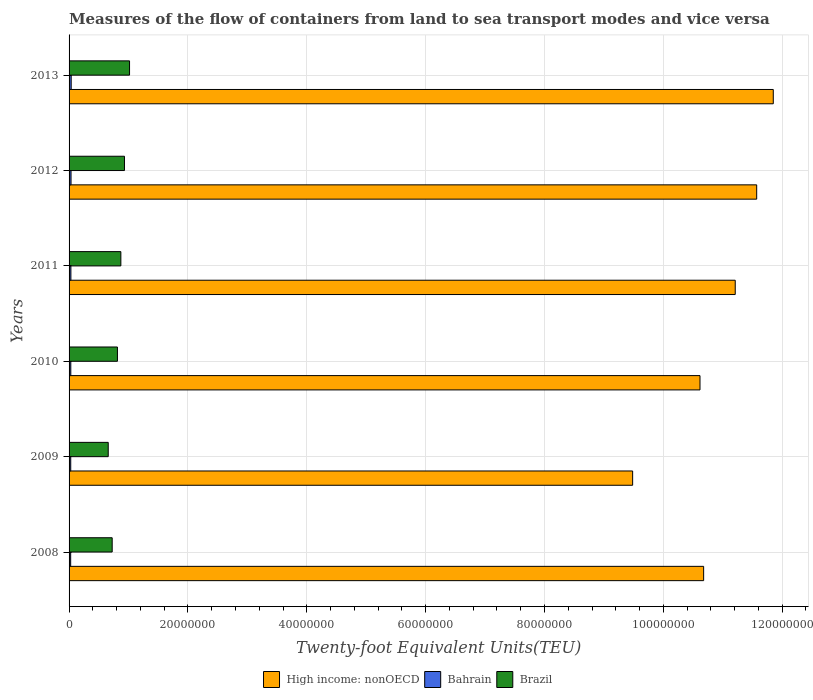How many different coloured bars are there?
Provide a short and direct response. 3. How many groups of bars are there?
Offer a very short reply. 6. How many bars are there on the 1st tick from the top?
Ensure brevity in your answer.  3. What is the label of the 5th group of bars from the top?
Offer a very short reply. 2009. In how many cases, is the number of bars for a given year not equal to the number of legend labels?
Your response must be concise. 0. What is the container port traffic in High income: nonOECD in 2011?
Offer a terse response. 1.12e+08. Across all years, what is the maximum container port traffic in High income: nonOECD?
Keep it short and to the point. 1.19e+08. Across all years, what is the minimum container port traffic in Brazil?
Give a very brief answer. 6.59e+06. In which year was the container port traffic in High income: nonOECD minimum?
Keep it short and to the point. 2009. What is the total container port traffic in Bahrain in the graph?
Give a very brief answer. 1.83e+06. What is the difference between the container port traffic in Bahrain in 2011 and that in 2012?
Provide a succinct answer. -2.30e+04. What is the difference between the container port traffic in Brazil in 2010 and the container port traffic in High income: nonOECD in 2012?
Provide a succinct answer. -1.08e+08. What is the average container port traffic in Bahrain per year?
Your answer should be very brief. 3.05e+05. In the year 2008, what is the difference between the container port traffic in Bahrain and container port traffic in Brazil?
Offer a very short reply. -6.99e+06. What is the ratio of the container port traffic in Brazil in 2010 to that in 2011?
Provide a succinct answer. 0.93. Is the container port traffic in Bahrain in 2010 less than that in 2012?
Offer a very short reply. Yes. What is the difference between the highest and the second highest container port traffic in Brazil?
Your response must be concise. 8.54e+05. What is the difference between the highest and the lowest container port traffic in Brazil?
Provide a short and direct response. 3.59e+06. Is the sum of the container port traffic in Brazil in 2008 and 2010 greater than the maximum container port traffic in Bahrain across all years?
Offer a terse response. Yes. What does the 3rd bar from the top in 2013 represents?
Provide a short and direct response. High income: nonOECD. What does the 3rd bar from the bottom in 2008 represents?
Provide a succinct answer. Brazil. Are all the bars in the graph horizontal?
Offer a very short reply. Yes. How many years are there in the graph?
Give a very brief answer. 6. What is the difference between two consecutive major ticks on the X-axis?
Give a very brief answer. 2.00e+07. Does the graph contain any zero values?
Make the answer very short. No. What is the title of the graph?
Offer a terse response. Measures of the flow of containers from land to sea transport modes and vice versa. Does "Small states" appear as one of the legend labels in the graph?
Keep it short and to the point. No. What is the label or title of the X-axis?
Keep it short and to the point. Twenty-foot Equivalent Units(TEU). What is the label or title of the Y-axis?
Offer a terse response. Years. What is the Twenty-foot Equivalent Units(TEU) in High income: nonOECD in 2008?
Make the answer very short. 1.07e+08. What is the Twenty-foot Equivalent Units(TEU) of Bahrain in 2008?
Offer a very short reply. 2.69e+05. What is the Twenty-foot Equivalent Units(TEU) of Brazil in 2008?
Ensure brevity in your answer.  7.26e+06. What is the Twenty-foot Equivalent Units(TEU) in High income: nonOECD in 2009?
Provide a succinct answer. 9.48e+07. What is the Twenty-foot Equivalent Units(TEU) in Bahrain in 2009?
Ensure brevity in your answer.  2.80e+05. What is the Twenty-foot Equivalent Units(TEU) in Brazil in 2009?
Offer a very short reply. 6.59e+06. What is the Twenty-foot Equivalent Units(TEU) in High income: nonOECD in 2010?
Your response must be concise. 1.06e+08. What is the Twenty-foot Equivalent Units(TEU) in Bahrain in 2010?
Your response must be concise. 2.90e+05. What is the Twenty-foot Equivalent Units(TEU) of Brazil in 2010?
Your answer should be compact. 8.14e+06. What is the Twenty-foot Equivalent Units(TEU) of High income: nonOECD in 2011?
Provide a short and direct response. 1.12e+08. What is the Twenty-foot Equivalent Units(TEU) of Bahrain in 2011?
Your response must be concise. 3.06e+05. What is the Twenty-foot Equivalent Units(TEU) of Brazil in 2011?
Your answer should be very brief. 8.71e+06. What is the Twenty-foot Equivalent Units(TEU) in High income: nonOECD in 2012?
Ensure brevity in your answer.  1.16e+08. What is the Twenty-foot Equivalent Units(TEU) of Bahrain in 2012?
Your response must be concise. 3.29e+05. What is the Twenty-foot Equivalent Units(TEU) of Brazil in 2012?
Your answer should be compact. 9.32e+06. What is the Twenty-foot Equivalent Units(TEU) of High income: nonOECD in 2013?
Provide a succinct answer. 1.19e+08. What is the Twenty-foot Equivalent Units(TEU) of Bahrain in 2013?
Give a very brief answer. 3.55e+05. What is the Twenty-foot Equivalent Units(TEU) in Brazil in 2013?
Make the answer very short. 1.02e+07. Across all years, what is the maximum Twenty-foot Equivalent Units(TEU) in High income: nonOECD?
Give a very brief answer. 1.19e+08. Across all years, what is the maximum Twenty-foot Equivalent Units(TEU) of Bahrain?
Make the answer very short. 3.55e+05. Across all years, what is the maximum Twenty-foot Equivalent Units(TEU) of Brazil?
Your answer should be very brief. 1.02e+07. Across all years, what is the minimum Twenty-foot Equivalent Units(TEU) of High income: nonOECD?
Give a very brief answer. 9.48e+07. Across all years, what is the minimum Twenty-foot Equivalent Units(TEU) in Bahrain?
Provide a short and direct response. 2.69e+05. Across all years, what is the minimum Twenty-foot Equivalent Units(TEU) of Brazil?
Offer a very short reply. 6.59e+06. What is the total Twenty-foot Equivalent Units(TEU) in High income: nonOECD in the graph?
Offer a very short reply. 6.54e+08. What is the total Twenty-foot Equivalent Units(TEU) in Bahrain in the graph?
Make the answer very short. 1.83e+06. What is the total Twenty-foot Equivalent Units(TEU) in Brazil in the graph?
Keep it short and to the point. 5.02e+07. What is the difference between the Twenty-foot Equivalent Units(TEU) in High income: nonOECD in 2008 and that in 2009?
Ensure brevity in your answer.  1.19e+07. What is the difference between the Twenty-foot Equivalent Units(TEU) in Bahrain in 2008 and that in 2009?
Offer a terse response. -1.05e+04. What is the difference between the Twenty-foot Equivalent Units(TEU) in Brazil in 2008 and that in 2009?
Your answer should be compact. 6.66e+05. What is the difference between the Twenty-foot Equivalent Units(TEU) of High income: nonOECD in 2008 and that in 2010?
Your answer should be compact. 6.11e+05. What is the difference between the Twenty-foot Equivalent Units(TEU) in Bahrain in 2008 and that in 2010?
Offer a very short reply. -2.06e+04. What is the difference between the Twenty-foot Equivalent Units(TEU) in Brazil in 2008 and that in 2010?
Ensure brevity in your answer.  -8.82e+05. What is the difference between the Twenty-foot Equivalent Units(TEU) in High income: nonOECD in 2008 and that in 2011?
Give a very brief answer. -5.32e+06. What is the difference between the Twenty-foot Equivalent Units(TEU) in Bahrain in 2008 and that in 2011?
Give a very brief answer. -3.72e+04. What is the difference between the Twenty-foot Equivalent Units(TEU) of Brazil in 2008 and that in 2011?
Give a very brief answer. -1.46e+06. What is the difference between the Twenty-foot Equivalent Units(TEU) of High income: nonOECD in 2008 and that in 2012?
Give a very brief answer. -8.93e+06. What is the difference between the Twenty-foot Equivalent Units(TEU) in Bahrain in 2008 and that in 2012?
Keep it short and to the point. -6.01e+04. What is the difference between the Twenty-foot Equivalent Units(TEU) of Brazil in 2008 and that in 2012?
Give a very brief answer. -2.07e+06. What is the difference between the Twenty-foot Equivalent Units(TEU) of High income: nonOECD in 2008 and that in 2013?
Ensure brevity in your answer.  -1.17e+07. What is the difference between the Twenty-foot Equivalent Units(TEU) of Bahrain in 2008 and that in 2013?
Your answer should be compact. -8.62e+04. What is the difference between the Twenty-foot Equivalent Units(TEU) in Brazil in 2008 and that in 2013?
Your answer should be compact. -2.92e+06. What is the difference between the Twenty-foot Equivalent Units(TEU) of High income: nonOECD in 2009 and that in 2010?
Offer a terse response. -1.13e+07. What is the difference between the Twenty-foot Equivalent Units(TEU) of Bahrain in 2009 and that in 2010?
Make the answer very short. -1.02e+04. What is the difference between the Twenty-foot Equivalent Units(TEU) in Brazil in 2009 and that in 2010?
Your answer should be very brief. -1.55e+06. What is the difference between the Twenty-foot Equivalent Units(TEU) in High income: nonOECD in 2009 and that in 2011?
Keep it short and to the point. -1.73e+07. What is the difference between the Twenty-foot Equivalent Units(TEU) of Bahrain in 2009 and that in 2011?
Offer a terse response. -2.67e+04. What is the difference between the Twenty-foot Equivalent Units(TEU) of Brazil in 2009 and that in 2011?
Provide a succinct answer. -2.12e+06. What is the difference between the Twenty-foot Equivalent Units(TEU) of High income: nonOECD in 2009 and that in 2012?
Offer a very short reply. -2.09e+07. What is the difference between the Twenty-foot Equivalent Units(TEU) in Bahrain in 2009 and that in 2012?
Provide a short and direct response. -4.97e+04. What is the difference between the Twenty-foot Equivalent Units(TEU) in Brazil in 2009 and that in 2012?
Provide a short and direct response. -2.73e+06. What is the difference between the Twenty-foot Equivalent Units(TEU) in High income: nonOECD in 2009 and that in 2013?
Provide a succinct answer. -2.37e+07. What is the difference between the Twenty-foot Equivalent Units(TEU) in Bahrain in 2009 and that in 2013?
Your answer should be very brief. -7.57e+04. What is the difference between the Twenty-foot Equivalent Units(TEU) in Brazil in 2009 and that in 2013?
Provide a succinct answer. -3.59e+06. What is the difference between the Twenty-foot Equivalent Units(TEU) of High income: nonOECD in 2010 and that in 2011?
Give a very brief answer. -5.93e+06. What is the difference between the Twenty-foot Equivalent Units(TEU) in Bahrain in 2010 and that in 2011?
Give a very brief answer. -1.65e+04. What is the difference between the Twenty-foot Equivalent Units(TEU) of Brazil in 2010 and that in 2011?
Provide a succinct answer. -5.76e+05. What is the difference between the Twenty-foot Equivalent Units(TEU) in High income: nonOECD in 2010 and that in 2012?
Your answer should be very brief. -9.54e+06. What is the difference between the Twenty-foot Equivalent Units(TEU) in Bahrain in 2010 and that in 2012?
Offer a terse response. -3.95e+04. What is the difference between the Twenty-foot Equivalent Units(TEU) in Brazil in 2010 and that in 2012?
Offer a very short reply. -1.18e+06. What is the difference between the Twenty-foot Equivalent Units(TEU) in High income: nonOECD in 2010 and that in 2013?
Keep it short and to the point. -1.23e+07. What is the difference between the Twenty-foot Equivalent Units(TEU) in Bahrain in 2010 and that in 2013?
Give a very brief answer. -6.55e+04. What is the difference between the Twenty-foot Equivalent Units(TEU) of Brazil in 2010 and that in 2013?
Offer a terse response. -2.04e+06. What is the difference between the Twenty-foot Equivalent Units(TEU) in High income: nonOECD in 2011 and that in 2012?
Your answer should be compact. -3.61e+06. What is the difference between the Twenty-foot Equivalent Units(TEU) in Bahrain in 2011 and that in 2012?
Give a very brief answer. -2.30e+04. What is the difference between the Twenty-foot Equivalent Units(TEU) in Brazil in 2011 and that in 2012?
Give a very brief answer. -6.08e+05. What is the difference between the Twenty-foot Equivalent Units(TEU) in High income: nonOECD in 2011 and that in 2013?
Offer a terse response. -6.40e+06. What is the difference between the Twenty-foot Equivalent Units(TEU) in Bahrain in 2011 and that in 2013?
Your response must be concise. -4.90e+04. What is the difference between the Twenty-foot Equivalent Units(TEU) of Brazil in 2011 and that in 2013?
Provide a succinct answer. -1.46e+06. What is the difference between the Twenty-foot Equivalent Units(TEU) in High income: nonOECD in 2012 and that in 2013?
Your answer should be very brief. -2.79e+06. What is the difference between the Twenty-foot Equivalent Units(TEU) in Bahrain in 2012 and that in 2013?
Offer a terse response. -2.60e+04. What is the difference between the Twenty-foot Equivalent Units(TEU) in Brazil in 2012 and that in 2013?
Keep it short and to the point. -8.54e+05. What is the difference between the Twenty-foot Equivalent Units(TEU) of High income: nonOECD in 2008 and the Twenty-foot Equivalent Units(TEU) of Bahrain in 2009?
Ensure brevity in your answer.  1.07e+08. What is the difference between the Twenty-foot Equivalent Units(TEU) in High income: nonOECD in 2008 and the Twenty-foot Equivalent Units(TEU) in Brazil in 2009?
Offer a terse response. 1.00e+08. What is the difference between the Twenty-foot Equivalent Units(TEU) in Bahrain in 2008 and the Twenty-foot Equivalent Units(TEU) in Brazil in 2009?
Ensure brevity in your answer.  -6.32e+06. What is the difference between the Twenty-foot Equivalent Units(TEU) in High income: nonOECD in 2008 and the Twenty-foot Equivalent Units(TEU) in Bahrain in 2010?
Provide a succinct answer. 1.06e+08. What is the difference between the Twenty-foot Equivalent Units(TEU) of High income: nonOECD in 2008 and the Twenty-foot Equivalent Units(TEU) of Brazil in 2010?
Ensure brevity in your answer.  9.86e+07. What is the difference between the Twenty-foot Equivalent Units(TEU) of Bahrain in 2008 and the Twenty-foot Equivalent Units(TEU) of Brazil in 2010?
Make the answer very short. -7.87e+06. What is the difference between the Twenty-foot Equivalent Units(TEU) of High income: nonOECD in 2008 and the Twenty-foot Equivalent Units(TEU) of Bahrain in 2011?
Ensure brevity in your answer.  1.06e+08. What is the difference between the Twenty-foot Equivalent Units(TEU) of High income: nonOECD in 2008 and the Twenty-foot Equivalent Units(TEU) of Brazil in 2011?
Provide a short and direct response. 9.81e+07. What is the difference between the Twenty-foot Equivalent Units(TEU) of Bahrain in 2008 and the Twenty-foot Equivalent Units(TEU) of Brazil in 2011?
Your response must be concise. -8.45e+06. What is the difference between the Twenty-foot Equivalent Units(TEU) of High income: nonOECD in 2008 and the Twenty-foot Equivalent Units(TEU) of Bahrain in 2012?
Keep it short and to the point. 1.06e+08. What is the difference between the Twenty-foot Equivalent Units(TEU) of High income: nonOECD in 2008 and the Twenty-foot Equivalent Units(TEU) of Brazil in 2012?
Ensure brevity in your answer.  9.75e+07. What is the difference between the Twenty-foot Equivalent Units(TEU) in Bahrain in 2008 and the Twenty-foot Equivalent Units(TEU) in Brazil in 2012?
Your response must be concise. -9.05e+06. What is the difference between the Twenty-foot Equivalent Units(TEU) of High income: nonOECD in 2008 and the Twenty-foot Equivalent Units(TEU) of Bahrain in 2013?
Keep it short and to the point. 1.06e+08. What is the difference between the Twenty-foot Equivalent Units(TEU) of High income: nonOECD in 2008 and the Twenty-foot Equivalent Units(TEU) of Brazil in 2013?
Keep it short and to the point. 9.66e+07. What is the difference between the Twenty-foot Equivalent Units(TEU) of Bahrain in 2008 and the Twenty-foot Equivalent Units(TEU) of Brazil in 2013?
Keep it short and to the point. -9.91e+06. What is the difference between the Twenty-foot Equivalent Units(TEU) in High income: nonOECD in 2009 and the Twenty-foot Equivalent Units(TEU) in Bahrain in 2010?
Offer a terse response. 9.46e+07. What is the difference between the Twenty-foot Equivalent Units(TEU) of High income: nonOECD in 2009 and the Twenty-foot Equivalent Units(TEU) of Brazil in 2010?
Provide a short and direct response. 8.67e+07. What is the difference between the Twenty-foot Equivalent Units(TEU) in Bahrain in 2009 and the Twenty-foot Equivalent Units(TEU) in Brazil in 2010?
Offer a terse response. -7.86e+06. What is the difference between the Twenty-foot Equivalent Units(TEU) of High income: nonOECD in 2009 and the Twenty-foot Equivalent Units(TEU) of Bahrain in 2011?
Your answer should be very brief. 9.45e+07. What is the difference between the Twenty-foot Equivalent Units(TEU) of High income: nonOECD in 2009 and the Twenty-foot Equivalent Units(TEU) of Brazil in 2011?
Give a very brief answer. 8.61e+07. What is the difference between the Twenty-foot Equivalent Units(TEU) of Bahrain in 2009 and the Twenty-foot Equivalent Units(TEU) of Brazil in 2011?
Your response must be concise. -8.43e+06. What is the difference between the Twenty-foot Equivalent Units(TEU) of High income: nonOECD in 2009 and the Twenty-foot Equivalent Units(TEU) of Bahrain in 2012?
Offer a terse response. 9.45e+07. What is the difference between the Twenty-foot Equivalent Units(TEU) in High income: nonOECD in 2009 and the Twenty-foot Equivalent Units(TEU) in Brazil in 2012?
Offer a very short reply. 8.55e+07. What is the difference between the Twenty-foot Equivalent Units(TEU) of Bahrain in 2009 and the Twenty-foot Equivalent Units(TEU) of Brazil in 2012?
Ensure brevity in your answer.  -9.04e+06. What is the difference between the Twenty-foot Equivalent Units(TEU) in High income: nonOECD in 2009 and the Twenty-foot Equivalent Units(TEU) in Bahrain in 2013?
Make the answer very short. 9.45e+07. What is the difference between the Twenty-foot Equivalent Units(TEU) in High income: nonOECD in 2009 and the Twenty-foot Equivalent Units(TEU) in Brazil in 2013?
Make the answer very short. 8.47e+07. What is the difference between the Twenty-foot Equivalent Units(TEU) in Bahrain in 2009 and the Twenty-foot Equivalent Units(TEU) in Brazil in 2013?
Your answer should be compact. -9.90e+06. What is the difference between the Twenty-foot Equivalent Units(TEU) of High income: nonOECD in 2010 and the Twenty-foot Equivalent Units(TEU) of Bahrain in 2011?
Your response must be concise. 1.06e+08. What is the difference between the Twenty-foot Equivalent Units(TEU) in High income: nonOECD in 2010 and the Twenty-foot Equivalent Units(TEU) in Brazil in 2011?
Keep it short and to the point. 9.75e+07. What is the difference between the Twenty-foot Equivalent Units(TEU) of Bahrain in 2010 and the Twenty-foot Equivalent Units(TEU) of Brazil in 2011?
Keep it short and to the point. -8.42e+06. What is the difference between the Twenty-foot Equivalent Units(TEU) of High income: nonOECD in 2010 and the Twenty-foot Equivalent Units(TEU) of Bahrain in 2012?
Your answer should be compact. 1.06e+08. What is the difference between the Twenty-foot Equivalent Units(TEU) of High income: nonOECD in 2010 and the Twenty-foot Equivalent Units(TEU) of Brazil in 2012?
Ensure brevity in your answer.  9.69e+07. What is the difference between the Twenty-foot Equivalent Units(TEU) in Bahrain in 2010 and the Twenty-foot Equivalent Units(TEU) in Brazil in 2012?
Offer a very short reply. -9.03e+06. What is the difference between the Twenty-foot Equivalent Units(TEU) in High income: nonOECD in 2010 and the Twenty-foot Equivalent Units(TEU) in Bahrain in 2013?
Keep it short and to the point. 1.06e+08. What is the difference between the Twenty-foot Equivalent Units(TEU) of High income: nonOECD in 2010 and the Twenty-foot Equivalent Units(TEU) of Brazil in 2013?
Give a very brief answer. 9.60e+07. What is the difference between the Twenty-foot Equivalent Units(TEU) in Bahrain in 2010 and the Twenty-foot Equivalent Units(TEU) in Brazil in 2013?
Your response must be concise. -9.89e+06. What is the difference between the Twenty-foot Equivalent Units(TEU) in High income: nonOECD in 2011 and the Twenty-foot Equivalent Units(TEU) in Bahrain in 2012?
Provide a succinct answer. 1.12e+08. What is the difference between the Twenty-foot Equivalent Units(TEU) of High income: nonOECD in 2011 and the Twenty-foot Equivalent Units(TEU) of Brazil in 2012?
Make the answer very short. 1.03e+08. What is the difference between the Twenty-foot Equivalent Units(TEU) of Bahrain in 2011 and the Twenty-foot Equivalent Units(TEU) of Brazil in 2012?
Offer a very short reply. -9.02e+06. What is the difference between the Twenty-foot Equivalent Units(TEU) in High income: nonOECD in 2011 and the Twenty-foot Equivalent Units(TEU) in Bahrain in 2013?
Ensure brevity in your answer.  1.12e+08. What is the difference between the Twenty-foot Equivalent Units(TEU) of High income: nonOECD in 2011 and the Twenty-foot Equivalent Units(TEU) of Brazil in 2013?
Give a very brief answer. 1.02e+08. What is the difference between the Twenty-foot Equivalent Units(TEU) of Bahrain in 2011 and the Twenty-foot Equivalent Units(TEU) of Brazil in 2013?
Your answer should be compact. -9.87e+06. What is the difference between the Twenty-foot Equivalent Units(TEU) in High income: nonOECD in 2012 and the Twenty-foot Equivalent Units(TEU) in Bahrain in 2013?
Offer a very short reply. 1.15e+08. What is the difference between the Twenty-foot Equivalent Units(TEU) in High income: nonOECD in 2012 and the Twenty-foot Equivalent Units(TEU) in Brazil in 2013?
Offer a very short reply. 1.06e+08. What is the difference between the Twenty-foot Equivalent Units(TEU) of Bahrain in 2012 and the Twenty-foot Equivalent Units(TEU) of Brazil in 2013?
Provide a succinct answer. -9.85e+06. What is the average Twenty-foot Equivalent Units(TEU) of High income: nonOECD per year?
Keep it short and to the point. 1.09e+08. What is the average Twenty-foot Equivalent Units(TEU) in Bahrain per year?
Offer a very short reply. 3.05e+05. What is the average Twenty-foot Equivalent Units(TEU) of Brazil per year?
Ensure brevity in your answer.  8.37e+06. In the year 2008, what is the difference between the Twenty-foot Equivalent Units(TEU) in High income: nonOECD and Twenty-foot Equivalent Units(TEU) in Bahrain?
Give a very brief answer. 1.07e+08. In the year 2008, what is the difference between the Twenty-foot Equivalent Units(TEU) in High income: nonOECD and Twenty-foot Equivalent Units(TEU) in Brazil?
Your answer should be very brief. 9.95e+07. In the year 2008, what is the difference between the Twenty-foot Equivalent Units(TEU) in Bahrain and Twenty-foot Equivalent Units(TEU) in Brazil?
Offer a terse response. -6.99e+06. In the year 2009, what is the difference between the Twenty-foot Equivalent Units(TEU) of High income: nonOECD and Twenty-foot Equivalent Units(TEU) of Bahrain?
Ensure brevity in your answer.  9.46e+07. In the year 2009, what is the difference between the Twenty-foot Equivalent Units(TEU) of High income: nonOECD and Twenty-foot Equivalent Units(TEU) of Brazil?
Offer a terse response. 8.82e+07. In the year 2009, what is the difference between the Twenty-foot Equivalent Units(TEU) of Bahrain and Twenty-foot Equivalent Units(TEU) of Brazil?
Provide a short and direct response. -6.31e+06. In the year 2010, what is the difference between the Twenty-foot Equivalent Units(TEU) in High income: nonOECD and Twenty-foot Equivalent Units(TEU) in Bahrain?
Provide a short and direct response. 1.06e+08. In the year 2010, what is the difference between the Twenty-foot Equivalent Units(TEU) in High income: nonOECD and Twenty-foot Equivalent Units(TEU) in Brazil?
Keep it short and to the point. 9.80e+07. In the year 2010, what is the difference between the Twenty-foot Equivalent Units(TEU) of Bahrain and Twenty-foot Equivalent Units(TEU) of Brazil?
Ensure brevity in your answer.  -7.85e+06. In the year 2011, what is the difference between the Twenty-foot Equivalent Units(TEU) of High income: nonOECD and Twenty-foot Equivalent Units(TEU) of Bahrain?
Your response must be concise. 1.12e+08. In the year 2011, what is the difference between the Twenty-foot Equivalent Units(TEU) of High income: nonOECD and Twenty-foot Equivalent Units(TEU) of Brazil?
Keep it short and to the point. 1.03e+08. In the year 2011, what is the difference between the Twenty-foot Equivalent Units(TEU) of Bahrain and Twenty-foot Equivalent Units(TEU) of Brazil?
Ensure brevity in your answer.  -8.41e+06. In the year 2012, what is the difference between the Twenty-foot Equivalent Units(TEU) of High income: nonOECD and Twenty-foot Equivalent Units(TEU) of Bahrain?
Offer a terse response. 1.15e+08. In the year 2012, what is the difference between the Twenty-foot Equivalent Units(TEU) of High income: nonOECD and Twenty-foot Equivalent Units(TEU) of Brazil?
Give a very brief answer. 1.06e+08. In the year 2012, what is the difference between the Twenty-foot Equivalent Units(TEU) of Bahrain and Twenty-foot Equivalent Units(TEU) of Brazil?
Ensure brevity in your answer.  -8.99e+06. In the year 2013, what is the difference between the Twenty-foot Equivalent Units(TEU) of High income: nonOECD and Twenty-foot Equivalent Units(TEU) of Bahrain?
Keep it short and to the point. 1.18e+08. In the year 2013, what is the difference between the Twenty-foot Equivalent Units(TEU) of High income: nonOECD and Twenty-foot Equivalent Units(TEU) of Brazil?
Your response must be concise. 1.08e+08. In the year 2013, what is the difference between the Twenty-foot Equivalent Units(TEU) of Bahrain and Twenty-foot Equivalent Units(TEU) of Brazil?
Offer a very short reply. -9.82e+06. What is the ratio of the Twenty-foot Equivalent Units(TEU) in High income: nonOECD in 2008 to that in 2009?
Offer a very short reply. 1.13. What is the ratio of the Twenty-foot Equivalent Units(TEU) of Bahrain in 2008 to that in 2009?
Provide a short and direct response. 0.96. What is the ratio of the Twenty-foot Equivalent Units(TEU) in Brazil in 2008 to that in 2009?
Your answer should be very brief. 1.1. What is the ratio of the Twenty-foot Equivalent Units(TEU) of High income: nonOECD in 2008 to that in 2010?
Provide a succinct answer. 1.01. What is the ratio of the Twenty-foot Equivalent Units(TEU) of Bahrain in 2008 to that in 2010?
Keep it short and to the point. 0.93. What is the ratio of the Twenty-foot Equivalent Units(TEU) in Brazil in 2008 to that in 2010?
Your answer should be very brief. 0.89. What is the ratio of the Twenty-foot Equivalent Units(TEU) of High income: nonOECD in 2008 to that in 2011?
Make the answer very short. 0.95. What is the ratio of the Twenty-foot Equivalent Units(TEU) of Bahrain in 2008 to that in 2011?
Provide a short and direct response. 0.88. What is the ratio of the Twenty-foot Equivalent Units(TEU) in Brazil in 2008 to that in 2011?
Give a very brief answer. 0.83. What is the ratio of the Twenty-foot Equivalent Units(TEU) in High income: nonOECD in 2008 to that in 2012?
Provide a short and direct response. 0.92. What is the ratio of the Twenty-foot Equivalent Units(TEU) of Bahrain in 2008 to that in 2012?
Offer a terse response. 0.82. What is the ratio of the Twenty-foot Equivalent Units(TEU) of Brazil in 2008 to that in 2012?
Your answer should be compact. 0.78. What is the ratio of the Twenty-foot Equivalent Units(TEU) in High income: nonOECD in 2008 to that in 2013?
Ensure brevity in your answer.  0.9. What is the ratio of the Twenty-foot Equivalent Units(TEU) of Bahrain in 2008 to that in 2013?
Make the answer very short. 0.76. What is the ratio of the Twenty-foot Equivalent Units(TEU) in Brazil in 2008 to that in 2013?
Offer a terse response. 0.71. What is the ratio of the Twenty-foot Equivalent Units(TEU) of High income: nonOECD in 2009 to that in 2010?
Your answer should be very brief. 0.89. What is the ratio of the Twenty-foot Equivalent Units(TEU) of Bahrain in 2009 to that in 2010?
Make the answer very short. 0.96. What is the ratio of the Twenty-foot Equivalent Units(TEU) of Brazil in 2009 to that in 2010?
Offer a terse response. 0.81. What is the ratio of the Twenty-foot Equivalent Units(TEU) in High income: nonOECD in 2009 to that in 2011?
Offer a very short reply. 0.85. What is the ratio of the Twenty-foot Equivalent Units(TEU) of Bahrain in 2009 to that in 2011?
Provide a succinct answer. 0.91. What is the ratio of the Twenty-foot Equivalent Units(TEU) of Brazil in 2009 to that in 2011?
Make the answer very short. 0.76. What is the ratio of the Twenty-foot Equivalent Units(TEU) of High income: nonOECD in 2009 to that in 2012?
Ensure brevity in your answer.  0.82. What is the ratio of the Twenty-foot Equivalent Units(TEU) in Bahrain in 2009 to that in 2012?
Your answer should be compact. 0.85. What is the ratio of the Twenty-foot Equivalent Units(TEU) of Brazil in 2009 to that in 2012?
Offer a terse response. 0.71. What is the ratio of the Twenty-foot Equivalent Units(TEU) of High income: nonOECD in 2009 to that in 2013?
Provide a short and direct response. 0.8. What is the ratio of the Twenty-foot Equivalent Units(TEU) of Bahrain in 2009 to that in 2013?
Your answer should be compact. 0.79. What is the ratio of the Twenty-foot Equivalent Units(TEU) in Brazil in 2009 to that in 2013?
Provide a succinct answer. 0.65. What is the ratio of the Twenty-foot Equivalent Units(TEU) of High income: nonOECD in 2010 to that in 2011?
Provide a succinct answer. 0.95. What is the ratio of the Twenty-foot Equivalent Units(TEU) of Bahrain in 2010 to that in 2011?
Ensure brevity in your answer.  0.95. What is the ratio of the Twenty-foot Equivalent Units(TEU) in Brazil in 2010 to that in 2011?
Keep it short and to the point. 0.93. What is the ratio of the Twenty-foot Equivalent Units(TEU) in High income: nonOECD in 2010 to that in 2012?
Ensure brevity in your answer.  0.92. What is the ratio of the Twenty-foot Equivalent Units(TEU) of Bahrain in 2010 to that in 2012?
Ensure brevity in your answer.  0.88. What is the ratio of the Twenty-foot Equivalent Units(TEU) of Brazil in 2010 to that in 2012?
Keep it short and to the point. 0.87. What is the ratio of the Twenty-foot Equivalent Units(TEU) in High income: nonOECD in 2010 to that in 2013?
Your response must be concise. 0.9. What is the ratio of the Twenty-foot Equivalent Units(TEU) in Bahrain in 2010 to that in 2013?
Keep it short and to the point. 0.82. What is the ratio of the Twenty-foot Equivalent Units(TEU) of Brazil in 2010 to that in 2013?
Provide a succinct answer. 0.8. What is the ratio of the Twenty-foot Equivalent Units(TEU) in High income: nonOECD in 2011 to that in 2012?
Your answer should be compact. 0.97. What is the ratio of the Twenty-foot Equivalent Units(TEU) in Bahrain in 2011 to that in 2012?
Provide a short and direct response. 0.93. What is the ratio of the Twenty-foot Equivalent Units(TEU) in Brazil in 2011 to that in 2012?
Offer a terse response. 0.93. What is the ratio of the Twenty-foot Equivalent Units(TEU) in High income: nonOECD in 2011 to that in 2013?
Ensure brevity in your answer.  0.95. What is the ratio of the Twenty-foot Equivalent Units(TEU) in Bahrain in 2011 to that in 2013?
Keep it short and to the point. 0.86. What is the ratio of the Twenty-foot Equivalent Units(TEU) of Brazil in 2011 to that in 2013?
Give a very brief answer. 0.86. What is the ratio of the Twenty-foot Equivalent Units(TEU) of High income: nonOECD in 2012 to that in 2013?
Make the answer very short. 0.98. What is the ratio of the Twenty-foot Equivalent Units(TEU) of Bahrain in 2012 to that in 2013?
Offer a very short reply. 0.93. What is the ratio of the Twenty-foot Equivalent Units(TEU) in Brazil in 2012 to that in 2013?
Give a very brief answer. 0.92. What is the difference between the highest and the second highest Twenty-foot Equivalent Units(TEU) of High income: nonOECD?
Offer a very short reply. 2.79e+06. What is the difference between the highest and the second highest Twenty-foot Equivalent Units(TEU) of Bahrain?
Offer a terse response. 2.60e+04. What is the difference between the highest and the second highest Twenty-foot Equivalent Units(TEU) in Brazil?
Ensure brevity in your answer.  8.54e+05. What is the difference between the highest and the lowest Twenty-foot Equivalent Units(TEU) of High income: nonOECD?
Make the answer very short. 2.37e+07. What is the difference between the highest and the lowest Twenty-foot Equivalent Units(TEU) in Bahrain?
Your answer should be very brief. 8.62e+04. What is the difference between the highest and the lowest Twenty-foot Equivalent Units(TEU) in Brazil?
Ensure brevity in your answer.  3.59e+06. 